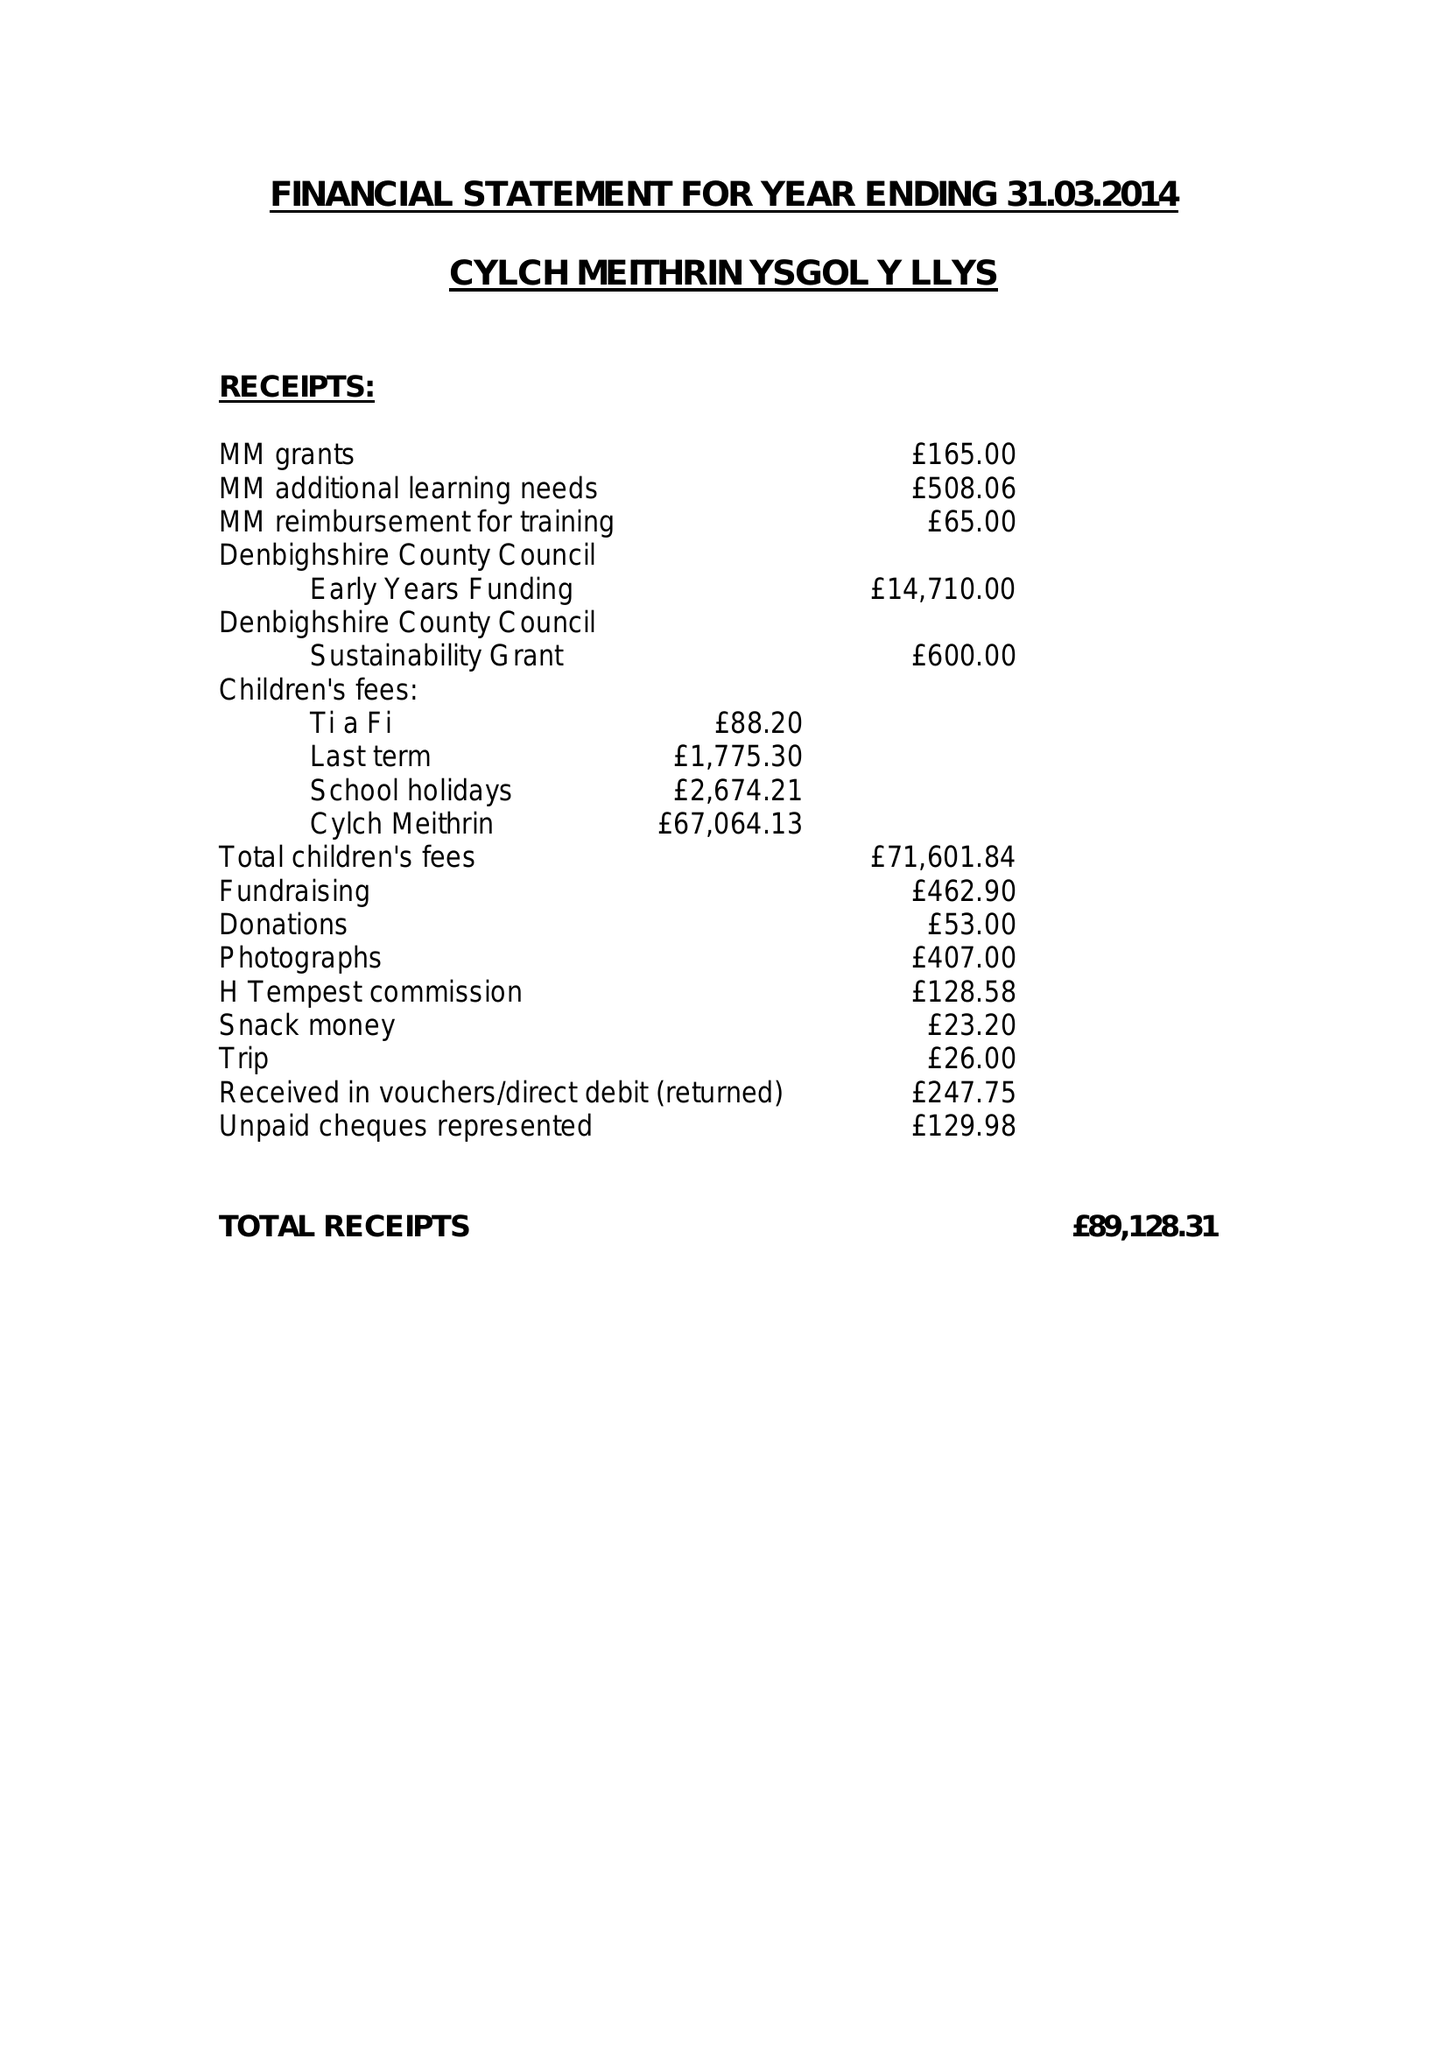What is the value for the address__postcode?
Answer the question using a single word or phrase. LL19 8RP 